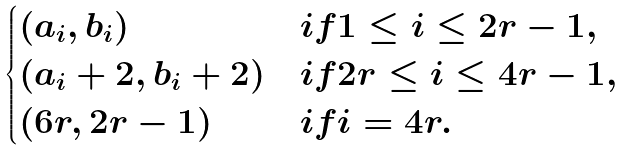<formula> <loc_0><loc_0><loc_500><loc_500>\begin{cases} ( a _ { i } , b _ { i } ) & i f 1 \leq i \leq 2 r - 1 , \\ ( a _ { i } + 2 , b _ { i } + 2 ) & i f 2 r \leq i \leq 4 r - 1 , \\ ( 6 r , 2 r - 1 ) & i f i = 4 r . \end{cases}</formula> 